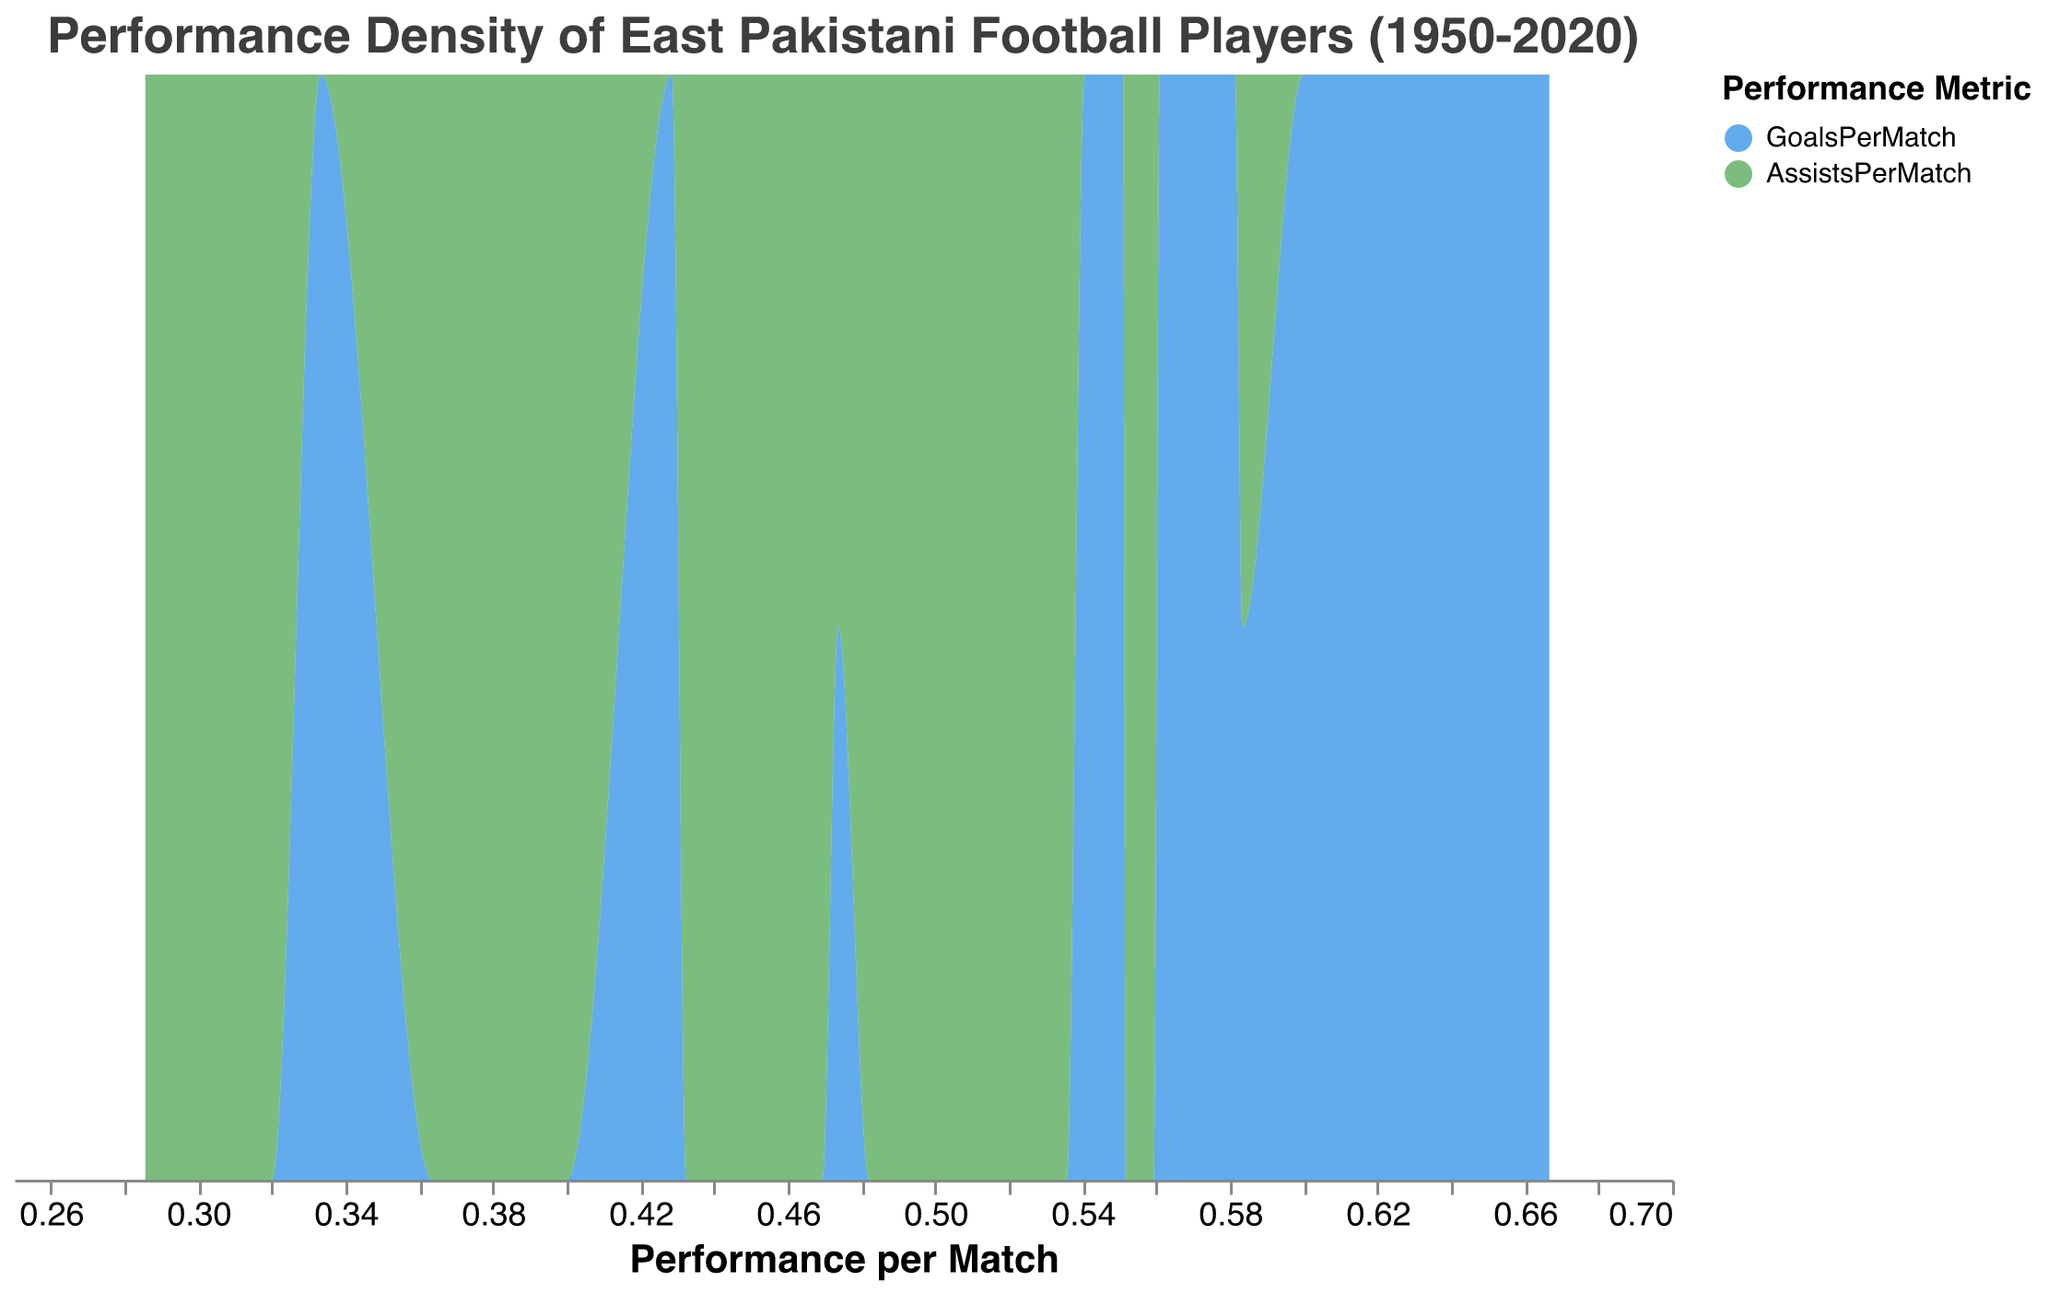What is the title of the plot? The title of the plot can be found at the top of the figure. It is "Performance Density of East Pakistani Football Players (1950-2020)."
Answer: Performance Density of East Pakistani Football Players (1950-2020) What is represented by the x-axis? The x-axis represents "Performance per Match," measured quantitatively.
Answer: Performance per Match What are the two performance metrics used in the density plot? The legend indicates that the two metrics are "GoalsPerMatch" and "AssistsPerMatch."
Answer: GoalsPerMatch and AssistsPerMatch Which performance metric has a higher density at the peak performance per match value? By examining the peak heights in the plot, we can see which area (color) reaches higher values. At the peak, "GoalsPerMatch" (blue color) has a higher density.
Answer: GoalsPerMatch What is the general trend of performance per match across different eras? The trends can be observed through the density areas across different performance levels. The later eras (2000-2010 and 2010-2020) exhibit higher performance levels per match, as indicated by the density shifting towards higher values on the x-axis.
Answer: Increasing trend across eras How do the densities of GoalsPerMatch and AssistsPerMatch compare in the era of 1950-1960? Comparing the blue and green areas specifically in this era shows that "GoalsPerMatch" and "AssistsPerMatch" have densities closer together with no significant gap between them.
Answer: Similar density levels Does the density plot indicate any era where performance metrics significantly overlap? By observing the density areas in different eras, significant overlaps are seen in the 2000-2010 and 2010-2020 eras where both metrics are very strong and have a substantial presence at similar performance per match values.
Answer: 2000-2010 and 2010-2020 Compare the density of AssistsPerMatch for the eras 1980-1990 and 1990-2000. Which era shows a higher density? By examining the green areas in the density plot, the era 1990-2000 shows a higher density of AssistsPerMatch compared to 1980-1990.
Answer: 1990-2000 What era shows the highest density for the GoalsPerMatch metric? Observing the blue areas in the plot, we can identify that the era 2010-2020 shows the highest density for GoalsPerMatch, as it peaks the highest on the x-axis.
Answer: 2010-2020 